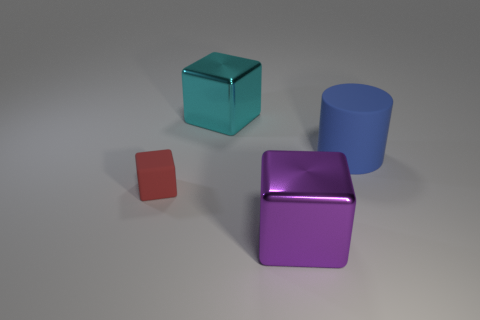Do the rubber block and the rubber cylinder have the same color?
Make the answer very short. No. Is the number of big metal objects less than the number of tiny cyan metallic objects?
Offer a terse response. No. There is a thing in front of the tiny red matte thing; does it have the same color as the tiny object?
Provide a succinct answer. No. What is the shape of the big metallic thing behind the red rubber block?
Offer a very short reply. Cube. There is a big cube that is behind the large rubber cylinder; is there a cylinder that is behind it?
Ensure brevity in your answer.  No. How many big blue cylinders are the same material as the red thing?
Provide a succinct answer. 1. What size is the shiny object behind the rubber object that is right of the shiny block that is behind the rubber cylinder?
Offer a very short reply. Large. How many large blue things are to the right of the big cyan metallic block?
Provide a short and direct response. 1. Is the number of large purple metal cubes greater than the number of gray rubber spheres?
Provide a short and direct response. Yes. There is a thing that is both on the right side of the tiny red block and in front of the big cylinder; how big is it?
Give a very brief answer. Large. 